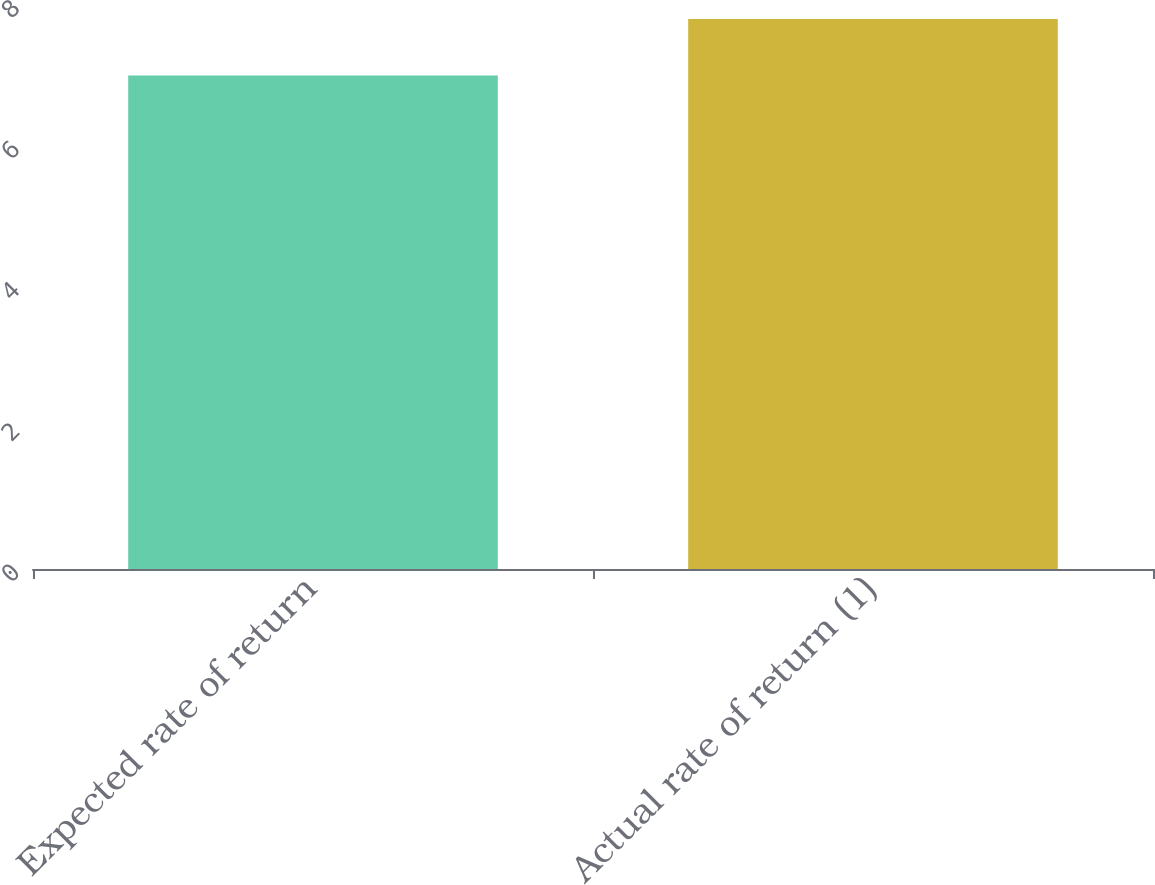Convert chart to OTSL. <chart><loc_0><loc_0><loc_500><loc_500><bar_chart><fcel>Expected rate of return<fcel>Actual rate of return (1)<nl><fcel>7<fcel>7.8<nl></chart> 